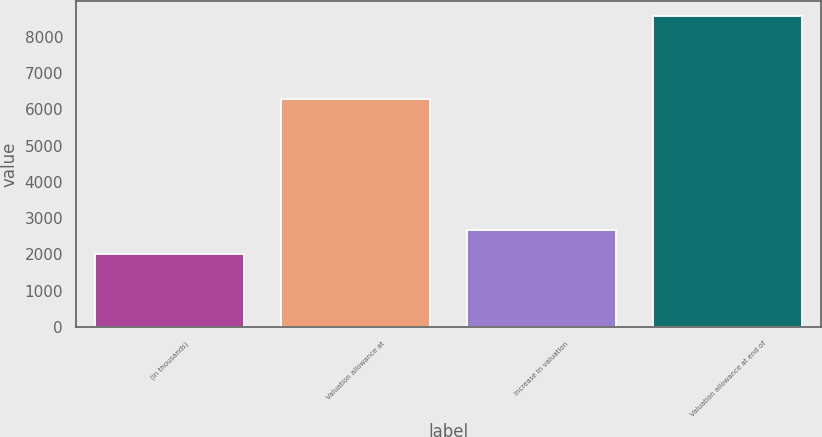Convert chart. <chart><loc_0><loc_0><loc_500><loc_500><bar_chart><fcel>(in thousands)<fcel>Valuation allowance at<fcel>Increase in valuation<fcel>Valuation allowance at end of<nl><fcel>2006<fcel>6279<fcel>2661.7<fcel>8563<nl></chart> 